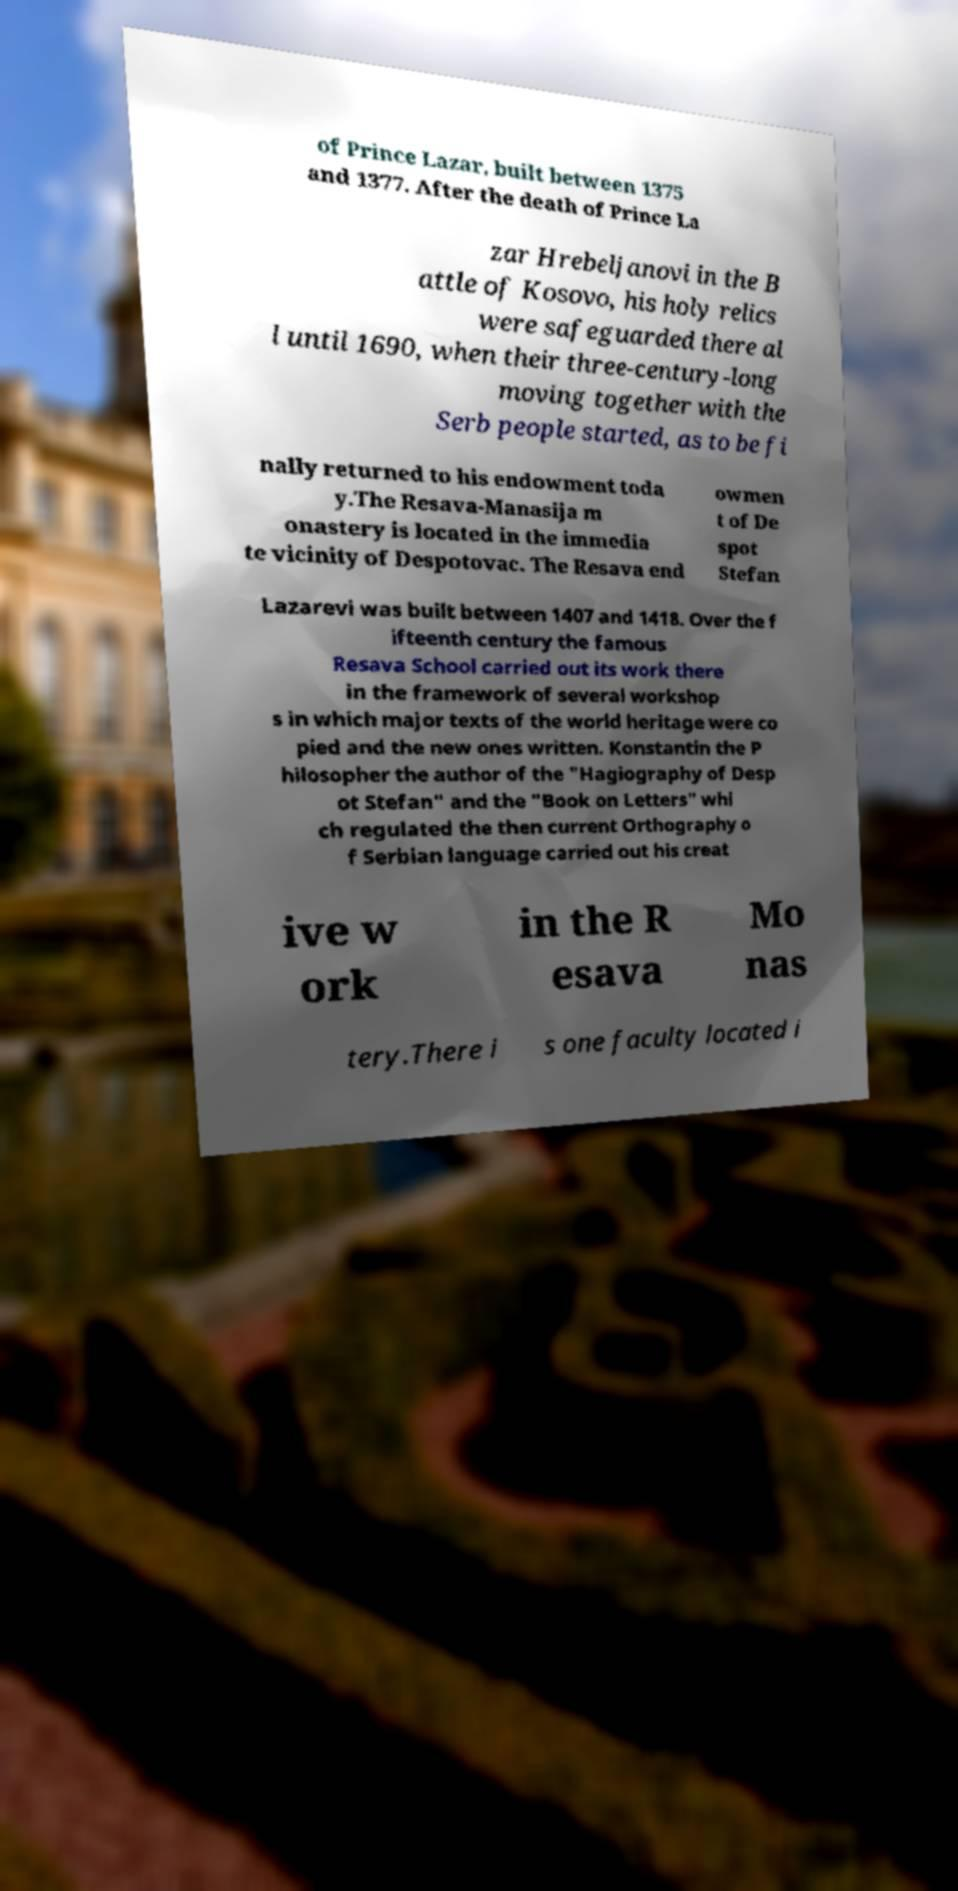Could you extract and type out the text from this image? of Prince Lazar, built between 1375 and 1377. After the death of Prince La zar Hrebeljanovi in the B attle of Kosovo, his holy relics were safeguarded there al l until 1690, when their three-century-long moving together with the Serb people started, as to be fi nally returned to his endowment toda y.The Resava-Manasija m onastery is located in the immedia te vicinity of Despotovac. The Resava end owmen t of De spot Stefan Lazarevi was built between 1407 and 1418. Over the f ifteenth century the famous Resava School carried out its work there in the framework of several workshop s in which major texts of the world heritage were co pied and the new ones written. Konstantin the P hilosopher the author of the "Hagiography of Desp ot Stefan" and the "Book on Letters" whi ch regulated the then current Orthography o f Serbian language carried out his creat ive w ork in the R esava Mo nas tery.There i s one faculty located i 